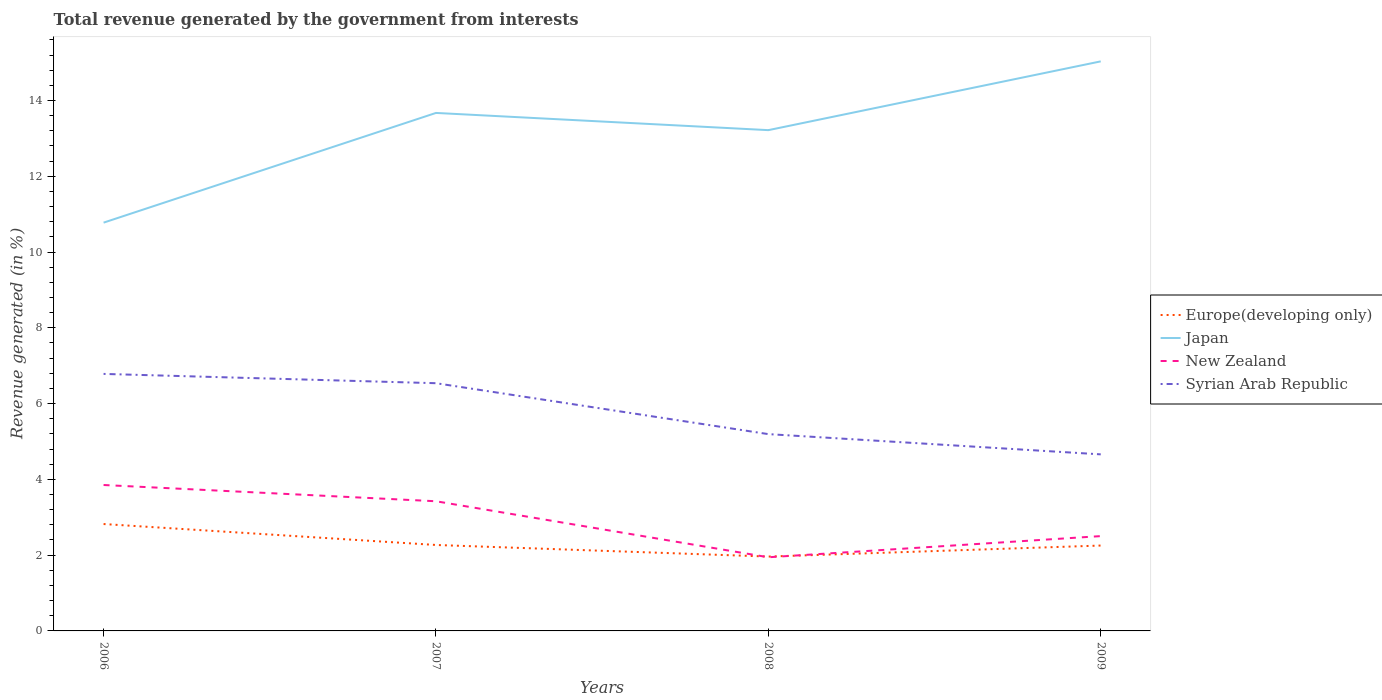Does the line corresponding to Japan intersect with the line corresponding to Europe(developing only)?
Ensure brevity in your answer.  No. Across all years, what is the maximum total revenue generated in Syrian Arab Republic?
Provide a succinct answer. 4.66. In which year was the total revenue generated in New Zealand maximum?
Ensure brevity in your answer.  2008. What is the total total revenue generated in Europe(developing only) in the graph?
Ensure brevity in your answer.  0.55. What is the difference between the highest and the second highest total revenue generated in Europe(developing only)?
Provide a succinct answer. 0.86. What is the difference between the highest and the lowest total revenue generated in Syrian Arab Republic?
Give a very brief answer. 2. Is the total revenue generated in Europe(developing only) strictly greater than the total revenue generated in Japan over the years?
Offer a very short reply. Yes. How many lines are there?
Make the answer very short. 4. What is the difference between two consecutive major ticks on the Y-axis?
Your response must be concise. 2. Are the values on the major ticks of Y-axis written in scientific E-notation?
Make the answer very short. No. Does the graph contain grids?
Your answer should be compact. No. How many legend labels are there?
Your response must be concise. 4. What is the title of the graph?
Offer a very short reply. Total revenue generated by the government from interests. Does "Paraguay" appear as one of the legend labels in the graph?
Ensure brevity in your answer.  No. What is the label or title of the X-axis?
Give a very brief answer. Years. What is the label or title of the Y-axis?
Your answer should be very brief. Revenue generated (in %). What is the Revenue generated (in %) of Europe(developing only) in 2006?
Provide a short and direct response. 2.82. What is the Revenue generated (in %) of Japan in 2006?
Provide a short and direct response. 10.78. What is the Revenue generated (in %) of New Zealand in 2006?
Provide a succinct answer. 3.85. What is the Revenue generated (in %) of Syrian Arab Republic in 2006?
Ensure brevity in your answer.  6.78. What is the Revenue generated (in %) in Europe(developing only) in 2007?
Ensure brevity in your answer.  2.27. What is the Revenue generated (in %) in Japan in 2007?
Keep it short and to the point. 13.67. What is the Revenue generated (in %) of New Zealand in 2007?
Keep it short and to the point. 3.42. What is the Revenue generated (in %) in Syrian Arab Republic in 2007?
Your answer should be compact. 6.54. What is the Revenue generated (in %) in Europe(developing only) in 2008?
Offer a very short reply. 1.96. What is the Revenue generated (in %) of Japan in 2008?
Give a very brief answer. 13.22. What is the Revenue generated (in %) of New Zealand in 2008?
Give a very brief answer. 1.94. What is the Revenue generated (in %) in Syrian Arab Republic in 2008?
Your response must be concise. 5.19. What is the Revenue generated (in %) in Europe(developing only) in 2009?
Your response must be concise. 2.25. What is the Revenue generated (in %) of Japan in 2009?
Provide a succinct answer. 15.03. What is the Revenue generated (in %) in New Zealand in 2009?
Make the answer very short. 2.5. What is the Revenue generated (in %) of Syrian Arab Republic in 2009?
Your answer should be very brief. 4.66. Across all years, what is the maximum Revenue generated (in %) of Europe(developing only)?
Keep it short and to the point. 2.82. Across all years, what is the maximum Revenue generated (in %) in Japan?
Ensure brevity in your answer.  15.03. Across all years, what is the maximum Revenue generated (in %) of New Zealand?
Give a very brief answer. 3.85. Across all years, what is the maximum Revenue generated (in %) in Syrian Arab Republic?
Your response must be concise. 6.78. Across all years, what is the minimum Revenue generated (in %) in Europe(developing only)?
Offer a very short reply. 1.96. Across all years, what is the minimum Revenue generated (in %) of Japan?
Provide a succinct answer. 10.78. Across all years, what is the minimum Revenue generated (in %) of New Zealand?
Provide a succinct answer. 1.94. Across all years, what is the minimum Revenue generated (in %) of Syrian Arab Republic?
Provide a short and direct response. 4.66. What is the total Revenue generated (in %) in Europe(developing only) in the graph?
Your answer should be very brief. 9.31. What is the total Revenue generated (in %) of Japan in the graph?
Offer a very short reply. 52.7. What is the total Revenue generated (in %) of New Zealand in the graph?
Your answer should be compact. 11.72. What is the total Revenue generated (in %) in Syrian Arab Republic in the graph?
Offer a terse response. 23.18. What is the difference between the Revenue generated (in %) of Europe(developing only) in 2006 and that in 2007?
Your response must be concise. 0.55. What is the difference between the Revenue generated (in %) in Japan in 2006 and that in 2007?
Your answer should be very brief. -2.9. What is the difference between the Revenue generated (in %) in New Zealand in 2006 and that in 2007?
Your answer should be very brief. 0.43. What is the difference between the Revenue generated (in %) in Syrian Arab Republic in 2006 and that in 2007?
Keep it short and to the point. 0.25. What is the difference between the Revenue generated (in %) of Europe(developing only) in 2006 and that in 2008?
Offer a terse response. 0.86. What is the difference between the Revenue generated (in %) in Japan in 2006 and that in 2008?
Your response must be concise. -2.44. What is the difference between the Revenue generated (in %) of New Zealand in 2006 and that in 2008?
Make the answer very short. 1.91. What is the difference between the Revenue generated (in %) in Syrian Arab Republic in 2006 and that in 2008?
Your answer should be very brief. 1.59. What is the difference between the Revenue generated (in %) of Europe(developing only) in 2006 and that in 2009?
Offer a very short reply. 0.57. What is the difference between the Revenue generated (in %) of Japan in 2006 and that in 2009?
Offer a very short reply. -4.26. What is the difference between the Revenue generated (in %) in New Zealand in 2006 and that in 2009?
Offer a terse response. 1.35. What is the difference between the Revenue generated (in %) of Syrian Arab Republic in 2006 and that in 2009?
Your response must be concise. 2.12. What is the difference between the Revenue generated (in %) in Europe(developing only) in 2007 and that in 2008?
Your answer should be compact. 0.31. What is the difference between the Revenue generated (in %) of Japan in 2007 and that in 2008?
Keep it short and to the point. 0.45. What is the difference between the Revenue generated (in %) in New Zealand in 2007 and that in 2008?
Provide a succinct answer. 1.48. What is the difference between the Revenue generated (in %) of Syrian Arab Republic in 2007 and that in 2008?
Your answer should be compact. 1.34. What is the difference between the Revenue generated (in %) of Europe(developing only) in 2007 and that in 2009?
Provide a succinct answer. 0.01. What is the difference between the Revenue generated (in %) in Japan in 2007 and that in 2009?
Offer a terse response. -1.36. What is the difference between the Revenue generated (in %) in New Zealand in 2007 and that in 2009?
Offer a very short reply. 0.92. What is the difference between the Revenue generated (in %) of Syrian Arab Republic in 2007 and that in 2009?
Your answer should be very brief. 1.88. What is the difference between the Revenue generated (in %) in Europe(developing only) in 2008 and that in 2009?
Make the answer very short. -0.29. What is the difference between the Revenue generated (in %) in Japan in 2008 and that in 2009?
Keep it short and to the point. -1.82. What is the difference between the Revenue generated (in %) in New Zealand in 2008 and that in 2009?
Provide a succinct answer. -0.56. What is the difference between the Revenue generated (in %) of Syrian Arab Republic in 2008 and that in 2009?
Offer a terse response. 0.53. What is the difference between the Revenue generated (in %) of Europe(developing only) in 2006 and the Revenue generated (in %) of Japan in 2007?
Make the answer very short. -10.85. What is the difference between the Revenue generated (in %) in Europe(developing only) in 2006 and the Revenue generated (in %) in New Zealand in 2007?
Your answer should be very brief. -0.6. What is the difference between the Revenue generated (in %) of Europe(developing only) in 2006 and the Revenue generated (in %) of Syrian Arab Republic in 2007?
Make the answer very short. -3.72. What is the difference between the Revenue generated (in %) of Japan in 2006 and the Revenue generated (in %) of New Zealand in 2007?
Your answer should be very brief. 7.35. What is the difference between the Revenue generated (in %) of Japan in 2006 and the Revenue generated (in %) of Syrian Arab Republic in 2007?
Your answer should be compact. 4.24. What is the difference between the Revenue generated (in %) in New Zealand in 2006 and the Revenue generated (in %) in Syrian Arab Republic in 2007?
Give a very brief answer. -2.69. What is the difference between the Revenue generated (in %) in Europe(developing only) in 2006 and the Revenue generated (in %) in Japan in 2008?
Provide a succinct answer. -10.4. What is the difference between the Revenue generated (in %) in Europe(developing only) in 2006 and the Revenue generated (in %) in New Zealand in 2008?
Offer a very short reply. 0.88. What is the difference between the Revenue generated (in %) in Europe(developing only) in 2006 and the Revenue generated (in %) in Syrian Arab Republic in 2008?
Ensure brevity in your answer.  -2.37. What is the difference between the Revenue generated (in %) in Japan in 2006 and the Revenue generated (in %) in New Zealand in 2008?
Make the answer very short. 8.83. What is the difference between the Revenue generated (in %) in Japan in 2006 and the Revenue generated (in %) in Syrian Arab Republic in 2008?
Provide a short and direct response. 5.58. What is the difference between the Revenue generated (in %) in New Zealand in 2006 and the Revenue generated (in %) in Syrian Arab Republic in 2008?
Your answer should be compact. -1.34. What is the difference between the Revenue generated (in %) of Europe(developing only) in 2006 and the Revenue generated (in %) of Japan in 2009?
Give a very brief answer. -12.21. What is the difference between the Revenue generated (in %) in Europe(developing only) in 2006 and the Revenue generated (in %) in New Zealand in 2009?
Your answer should be compact. 0.32. What is the difference between the Revenue generated (in %) of Europe(developing only) in 2006 and the Revenue generated (in %) of Syrian Arab Republic in 2009?
Your answer should be very brief. -1.84. What is the difference between the Revenue generated (in %) in Japan in 2006 and the Revenue generated (in %) in New Zealand in 2009?
Give a very brief answer. 8.27. What is the difference between the Revenue generated (in %) in Japan in 2006 and the Revenue generated (in %) in Syrian Arab Republic in 2009?
Offer a very short reply. 6.12. What is the difference between the Revenue generated (in %) in New Zealand in 2006 and the Revenue generated (in %) in Syrian Arab Republic in 2009?
Your answer should be compact. -0.81. What is the difference between the Revenue generated (in %) of Europe(developing only) in 2007 and the Revenue generated (in %) of Japan in 2008?
Ensure brevity in your answer.  -10.95. What is the difference between the Revenue generated (in %) in Europe(developing only) in 2007 and the Revenue generated (in %) in New Zealand in 2008?
Your answer should be very brief. 0.32. What is the difference between the Revenue generated (in %) of Europe(developing only) in 2007 and the Revenue generated (in %) of Syrian Arab Republic in 2008?
Keep it short and to the point. -2.93. What is the difference between the Revenue generated (in %) in Japan in 2007 and the Revenue generated (in %) in New Zealand in 2008?
Your response must be concise. 11.73. What is the difference between the Revenue generated (in %) of Japan in 2007 and the Revenue generated (in %) of Syrian Arab Republic in 2008?
Your answer should be compact. 8.48. What is the difference between the Revenue generated (in %) of New Zealand in 2007 and the Revenue generated (in %) of Syrian Arab Republic in 2008?
Provide a succinct answer. -1.77. What is the difference between the Revenue generated (in %) in Europe(developing only) in 2007 and the Revenue generated (in %) in Japan in 2009?
Provide a succinct answer. -12.76. What is the difference between the Revenue generated (in %) of Europe(developing only) in 2007 and the Revenue generated (in %) of New Zealand in 2009?
Provide a short and direct response. -0.23. What is the difference between the Revenue generated (in %) of Europe(developing only) in 2007 and the Revenue generated (in %) of Syrian Arab Republic in 2009?
Offer a terse response. -2.39. What is the difference between the Revenue generated (in %) of Japan in 2007 and the Revenue generated (in %) of New Zealand in 2009?
Your answer should be very brief. 11.17. What is the difference between the Revenue generated (in %) of Japan in 2007 and the Revenue generated (in %) of Syrian Arab Republic in 2009?
Your response must be concise. 9.01. What is the difference between the Revenue generated (in %) of New Zealand in 2007 and the Revenue generated (in %) of Syrian Arab Republic in 2009?
Keep it short and to the point. -1.24. What is the difference between the Revenue generated (in %) of Europe(developing only) in 2008 and the Revenue generated (in %) of Japan in 2009?
Provide a succinct answer. -13.07. What is the difference between the Revenue generated (in %) in Europe(developing only) in 2008 and the Revenue generated (in %) in New Zealand in 2009?
Give a very brief answer. -0.54. What is the difference between the Revenue generated (in %) of Europe(developing only) in 2008 and the Revenue generated (in %) of Syrian Arab Republic in 2009?
Make the answer very short. -2.7. What is the difference between the Revenue generated (in %) in Japan in 2008 and the Revenue generated (in %) in New Zealand in 2009?
Your answer should be very brief. 10.72. What is the difference between the Revenue generated (in %) of Japan in 2008 and the Revenue generated (in %) of Syrian Arab Republic in 2009?
Offer a terse response. 8.56. What is the difference between the Revenue generated (in %) in New Zealand in 2008 and the Revenue generated (in %) in Syrian Arab Republic in 2009?
Your response must be concise. -2.72. What is the average Revenue generated (in %) in Europe(developing only) per year?
Give a very brief answer. 2.33. What is the average Revenue generated (in %) of Japan per year?
Your answer should be very brief. 13.17. What is the average Revenue generated (in %) of New Zealand per year?
Your answer should be compact. 2.93. What is the average Revenue generated (in %) in Syrian Arab Republic per year?
Offer a terse response. 5.79. In the year 2006, what is the difference between the Revenue generated (in %) of Europe(developing only) and Revenue generated (in %) of Japan?
Your answer should be compact. -7.95. In the year 2006, what is the difference between the Revenue generated (in %) of Europe(developing only) and Revenue generated (in %) of New Zealand?
Make the answer very short. -1.03. In the year 2006, what is the difference between the Revenue generated (in %) in Europe(developing only) and Revenue generated (in %) in Syrian Arab Republic?
Offer a very short reply. -3.96. In the year 2006, what is the difference between the Revenue generated (in %) of Japan and Revenue generated (in %) of New Zealand?
Keep it short and to the point. 6.92. In the year 2006, what is the difference between the Revenue generated (in %) in Japan and Revenue generated (in %) in Syrian Arab Republic?
Make the answer very short. 3.99. In the year 2006, what is the difference between the Revenue generated (in %) in New Zealand and Revenue generated (in %) in Syrian Arab Republic?
Keep it short and to the point. -2.93. In the year 2007, what is the difference between the Revenue generated (in %) of Europe(developing only) and Revenue generated (in %) of Japan?
Offer a very short reply. -11.4. In the year 2007, what is the difference between the Revenue generated (in %) of Europe(developing only) and Revenue generated (in %) of New Zealand?
Your answer should be very brief. -1.15. In the year 2007, what is the difference between the Revenue generated (in %) in Europe(developing only) and Revenue generated (in %) in Syrian Arab Republic?
Your answer should be very brief. -4.27. In the year 2007, what is the difference between the Revenue generated (in %) of Japan and Revenue generated (in %) of New Zealand?
Your answer should be compact. 10.25. In the year 2007, what is the difference between the Revenue generated (in %) of Japan and Revenue generated (in %) of Syrian Arab Republic?
Give a very brief answer. 7.13. In the year 2007, what is the difference between the Revenue generated (in %) in New Zealand and Revenue generated (in %) in Syrian Arab Republic?
Offer a very short reply. -3.12. In the year 2008, what is the difference between the Revenue generated (in %) in Europe(developing only) and Revenue generated (in %) in Japan?
Your answer should be very brief. -11.26. In the year 2008, what is the difference between the Revenue generated (in %) in Europe(developing only) and Revenue generated (in %) in New Zealand?
Make the answer very short. 0.02. In the year 2008, what is the difference between the Revenue generated (in %) in Europe(developing only) and Revenue generated (in %) in Syrian Arab Republic?
Make the answer very short. -3.23. In the year 2008, what is the difference between the Revenue generated (in %) of Japan and Revenue generated (in %) of New Zealand?
Ensure brevity in your answer.  11.27. In the year 2008, what is the difference between the Revenue generated (in %) of Japan and Revenue generated (in %) of Syrian Arab Republic?
Provide a short and direct response. 8.02. In the year 2008, what is the difference between the Revenue generated (in %) in New Zealand and Revenue generated (in %) in Syrian Arab Republic?
Make the answer very short. -3.25. In the year 2009, what is the difference between the Revenue generated (in %) in Europe(developing only) and Revenue generated (in %) in Japan?
Offer a very short reply. -12.78. In the year 2009, what is the difference between the Revenue generated (in %) of Europe(developing only) and Revenue generated (in %) of New Zealand?
Offer a very short reply. -0.25. In the year 2009, what is the difference between the Revenue generated (in %) of Europe(developing only) and Revenue generated (in %) of Syrian Arab Republic?
Provide a succinct answer. -2.41. In the year 2009, what is the difference between the Revenue generated (in %) of Japan and Revenue generated (in %) of New Zealand?
Keep it short and to the point. 12.53. In the year 2009, what is the difference between the Revenue generated (in %) of Japan and Revenue generated (in %) of Syrian Arab Republic?
Provide a succinct answer. 10.37. In the year 2009, what is the difference between the Revenue generated (in %) of New Zealand and Revenue generated (in %) of Syrian Arab Republic?
Ensure brevity in your answer.  -2.16. What is the ratio of the Revenue generated (in %) of Europe(developing only) in 2006 to that in 2007?
Ensure brevity in your answer.  1.24. What is the ratio of the Revenue generated (in %) of Japan in 2006 to that in 2007?
Provide a short and direct response. 0.79. What is the ratio of the Revenue generated (in %) of New Zealand in 2006 to that in 2007?
Offer a terse response. 1.13. What is the ratio of the Revenue generated (in %) of Syrian Arab Republic in 2006 to that in 2007?
Ensure brevity in your answer.  1.04. What is the ratio of the Revenue generated (in %) of Europe(developing only) in 2006 to that in 2008?
Offer a very short reply. 1.44. What is the ratio of the Revenue generated (in %) of Japan in 2006 to that in 2008?
Offer a very short reply. 0.82. What is the ratio of the Revenue generated (in %) of New Zealand in 2006 to that in 2008?
Your answer should be very brief. 1.98. What is the ratio of the Revenue generated (in %) in Syrian Arab Republic in 2006 to that in 2008?
Your response must be concise. 1.31. What is the ratio of the Revenue generated (in %) of Europe(developing only) in 2006 to that in 2009?
Provide a short and direct response. 1.25. What is the ratio of the Revenue generated (in %) in Japan in 2006 to that in 2009?
Your response must be concise. 0.72. What is the ratio of the Revenue generated (in %) in New Zealand in 2006 to that in 2009?
Provide a succinct answer. 1.54. What is the ratio of the Revenue generated (in %) in Syrian Arab Republic in 2006 to that in 2009?
Offer a terse response. 1.46. What is the ratio of the Revenue generated (in %) in Europe(developing only) in 2007 to that in 2008?
Your response must be concise. 1.16. What is the ratio of the Revenue generated (in %) in Japan in 2007 to that in 2008?
Make the answer very short. 1.03. What is the ratio of the Revenue generated (in %) of New Zealand in 2007 to that in 2008?
Keep it short and to the point. 1.76. What is the ratio of the Revenue generated (in %) in Syrian Arab Republic in 2007 to that in 2008?
Your response must be concise. 1.26. What is the ratio of the Revenue generated (in %) in Europe(developing only) in 2007 to that in 2009?
Give a very brief answer. 1.01. What is the ratio of the Revenue generated (in %) of Japan in 2007 to that in 2009?
Make the answer very short. 0.91. What is the ratio of the Revenue generated (in %) in New Zealand in 2007 to that in 2009?
Make the answer very short. 1.37. What is the ratio of the Revenue generated (in %) of Syrian Arab Republic in 2007 to that in 2009?
Ensure brevity in your answer.  1.4. What is the ratio of the Revenue generated (in %) of Europe(developing only) in 2008 to that in 2009?
Keep it short and to the point. 0.87. What is the ratio of the Revenue generated (in %) of Japan in 2008 to that in 2009?
Keep it short and to the point. 0.88. What is the ratio of the Revenue generated (in %) in New Zealand in 2008 to that in 2009?
Provide a succinct answer. 0.78. What is the ratio of the Revenue generated (in %) in Syrian Arab Republic in 2008 to that in 2009?
Your response must be concise. 1.11. What is the difference between the highest and the second highest Revenue generated (in %) in Europe(developing only)?
Provide a short and direct response. 0.55. What is the difference between the highest and the second highest Revenue generated (in %) in Japan?
Keep it short and to the point. 1.36. What is the difference between the highest and the second highest Revenue generated (in %) of New Zealand?
Ensure brevity in your answer.  0.43. What is the difference between the highest and the second highest Revenue generated (in %) of Syrian Arab Republic?
Provide a succinct answer. 0.25. What is the difference between the highest and the lowest Revenue generated (in %) of Europe(developing only)?
Ensure brevity in your answer.  0.86. What is the difference between the highest and the lowest Revenue generated (in %) of Japan?
Keep it short and to the point. 4.26. What is the difference between the highest and the lowest Revenue generated (in %) of New Zealand?
Keep it short and to the point. 1.91. What is the difference between the highest and the lowest Revenue generated (in %) of Syrian Arab Republic?
Your answer should be compact. 2.12. 